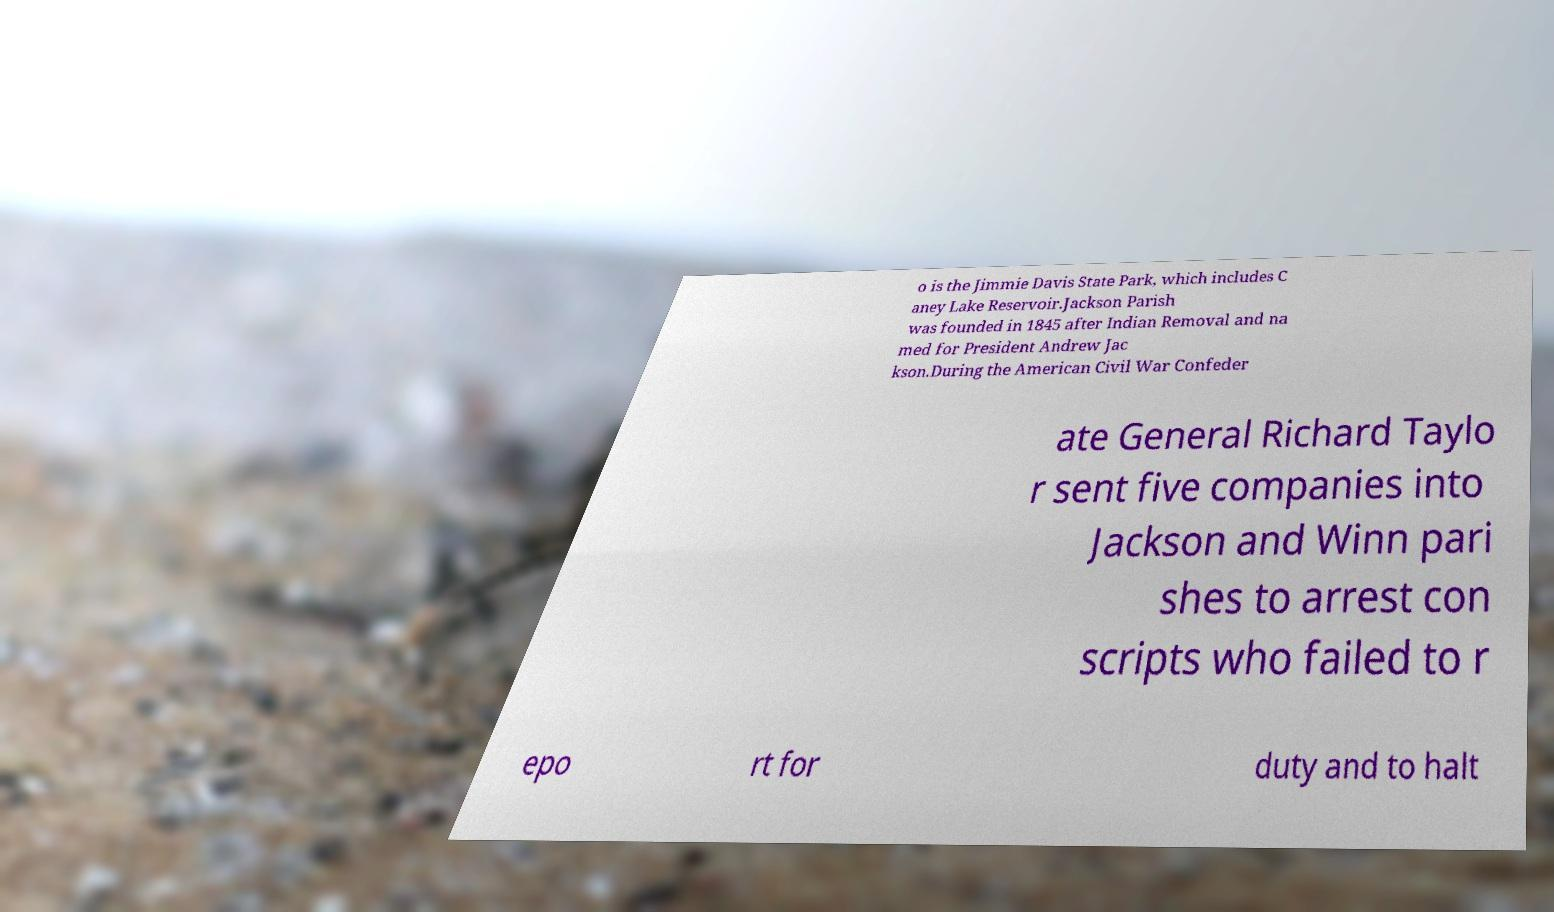Please identify and transcribe the text found in this image. o is the Jimmie Davis State Park, which includes C aney Lake Reservoir.Jackson Parish was founded in 1845 after Indian Removal and na med for President Andrew Jac kson.During the American Civil War Confeder ate General Richard Taylo r sent five companies into Jackson and Winn pari shes to arrest con scripts who failed to r epo rt for duty and to halt 